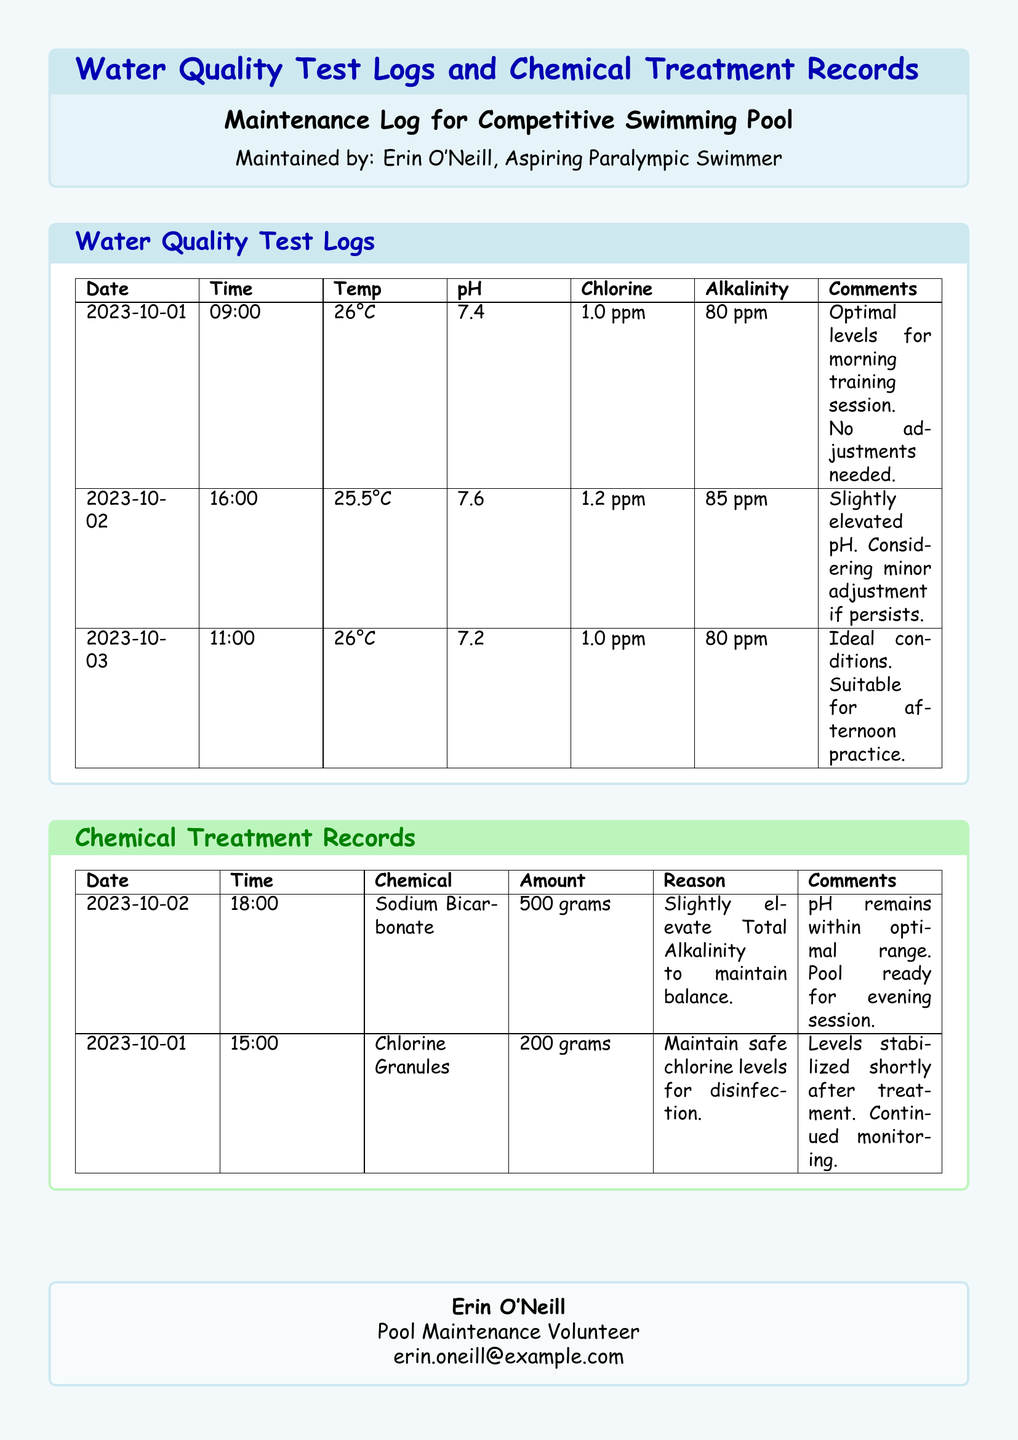what is the date of the first water quality test? The first water quality test was conducted on October 1, 2023.
Answer: October 1, 2023 what is the chlorine level recorded on October 02? The chlorine level recorded on that date was 1.2 ppm.
Answer: 1.2 ppm how much Sodium Bicarbonate was used in the chemical treatment? Sodium Bicarbonate was used in the amount of 500 grams.
Answer: 500 grams what temperature was recorded during the water quality test on October 03? The temperature recorded on that date was 26°C.
Answer: 26°C why was chlorine granules added on October 01? Chlorine granules were added to maintain safe chlorine levels for disinfection.
Answer: Maintain safe chlorine levels for disinfection how many total water quality tests are documented? There are three water quality tests documented in the logs.
Answer: Three what is the pH level considered optimal for training sessions? The optimal pH level noted in the logs is 7.4.
Answer: 7.4 what was the reason for adding Sodium Bicarbonate? The reason for adding it was to slightly elevate total alkalinity to maintain balance.
Answer: Slightly elevate Total Alkalinity to maintain balance which chemical was used on October 02, and what was its purpose? Sodium Bicarbonate was used to maintain balance in alkalinity.
Answer: Sodium Bicarbonate, maintain balance in alkalinity 